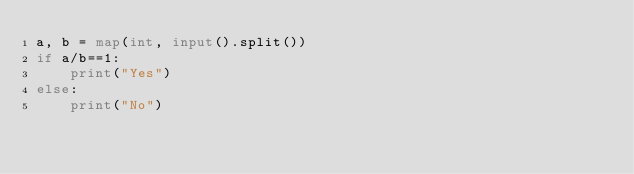<code> <loc_0><loc_0><loc_500><loc_500><_Python_>a, b = map(int, input().split())
if a/b==1:
    print("Yes")
else:
    print("No")</code> 